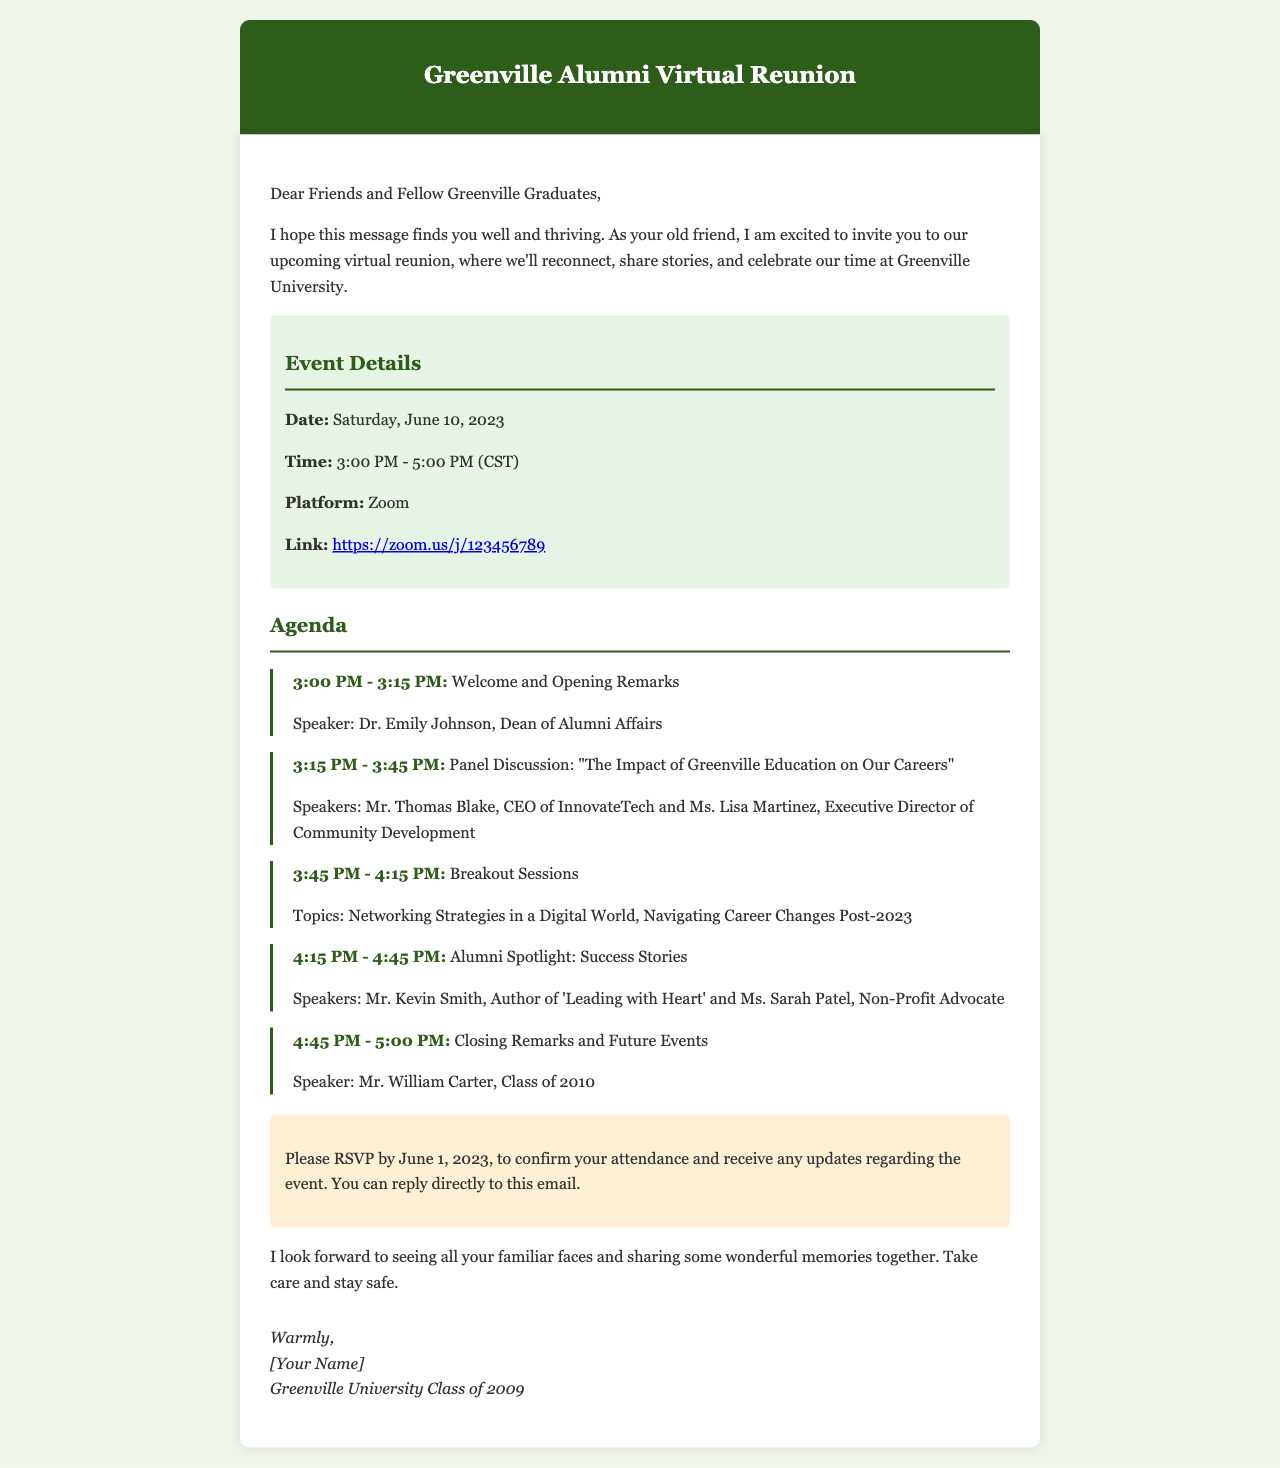What is the date of the reunion? The document specifies that the reunion will take place on Saturday, June 10, 2023.
Answer: Saturday, June 10, 2023 Who is the speaker for the opening remarks? The document lists Dr. Emily Johnson as the speaker for the opening remarks.
Answer: Dr. Emily Johnson What time does the panel discussion start? According to the agenda, the panel discussion starts at 3:15 PM.
Answer: 3:15 PM How long is the gamified breakout session scheduled for? The breakout sessions are scheduled from 3:45 PM to 4:15 PM, making it a duration of 30 minutes.
Answer: 30 minutes Which speaker is associated with the Alumni Spotlight session? The document mentions Mr. Kevin Smith and Ms. Sarah Patel as the speakers for the Alumni Spotlight session.
Answer: Mr. Kevin Smith and Ms. Sarah Patel What platform will the reunion be held on? It is stated in the document that the reunion will be held on Zoom.
Answer: Zoom How can attendees confirm their attendance? The document instructs attendees to RSVP by replying directly to the email.
Answer: Reply to this email When is the RSVP deadline? The document mentions that the RSVP deadline is June 1, 2023.
Answer: June 1, 2023 Who is giving the closing remarks? The document states that Mr. William Carter will give the closing remarks.
Answer: Mr. William Carter 